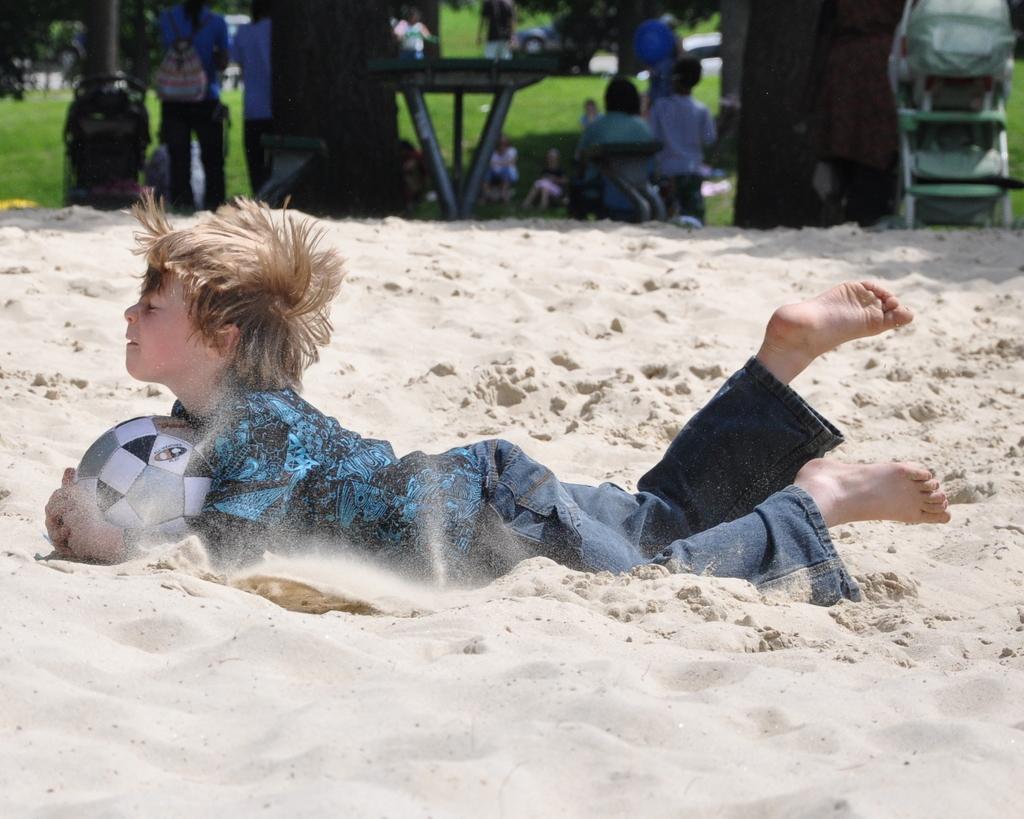In one or two sentences, can you explain what this image depicts? There is a boy playing with ball on a sand. In the background there is a table some people trees are there. There is a lawn in the background. 